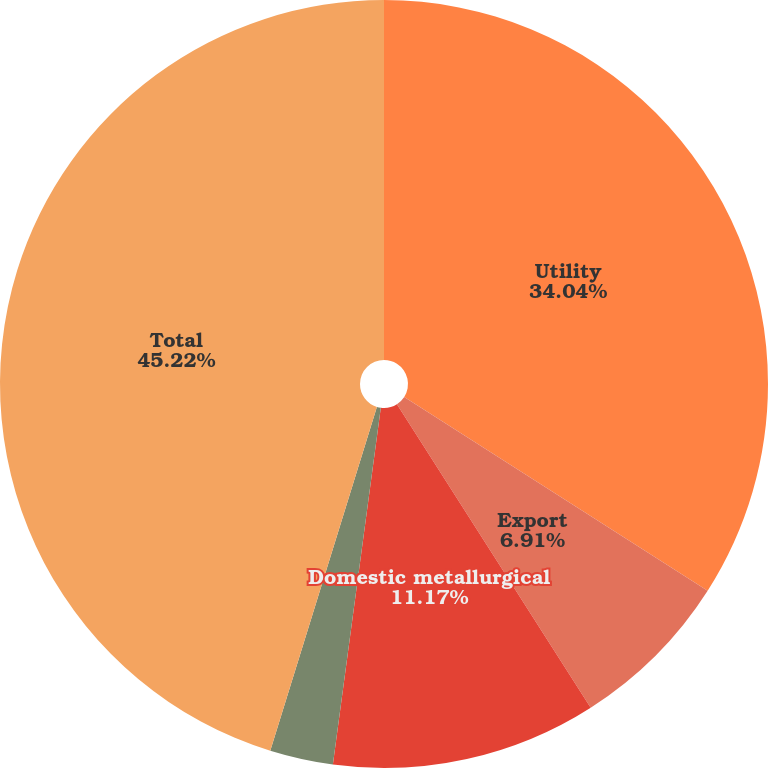Convert chart to OTSL. <chart><loc_0><loc_0><loc_500><loc_500><pie_chart><fcel>Utility<fcel>Export<fcel>Domestic metallurgical<fcel>Other<fcel>Total<nl><fcel>34.04%<fcel>6.91%<fcel>11.17%<fcel>2.66%<fcel>45.21%<nl></chart> 